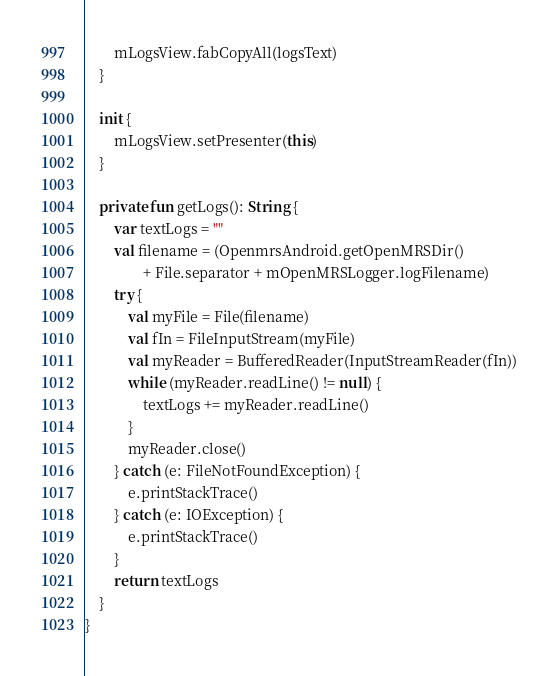<code> <loc_0><loc_0><loc_500><loc_500><_Kotlin_>        mLogsView.fabCopyAll(logsText)
    }

    init {
        mLogsView.setPresenter(this)
    }

    private fun getLogs(): String {
        var textLogs = ""
        val filename = (OpenmrsAndroid.getOpenMRSDir()
                + File.separator + mOpenMRSLogger.logFilename)
        try {
            val myFile = File(filename)
            val fIn = FileInputStream(myFile)
            val myReader = BufferedReader(InputStreamReader(fIn))
            while (myReader.readLine() != null) {
                textLogs += myReader.readLine()
            }
            myReader.close()
        } catch (e: FileNotFoundException) {
            e.printStackTrace()
        } catch (e: IOException) {
            e.printStackTrace()
        }
        return textLogs
    }
}</code> 